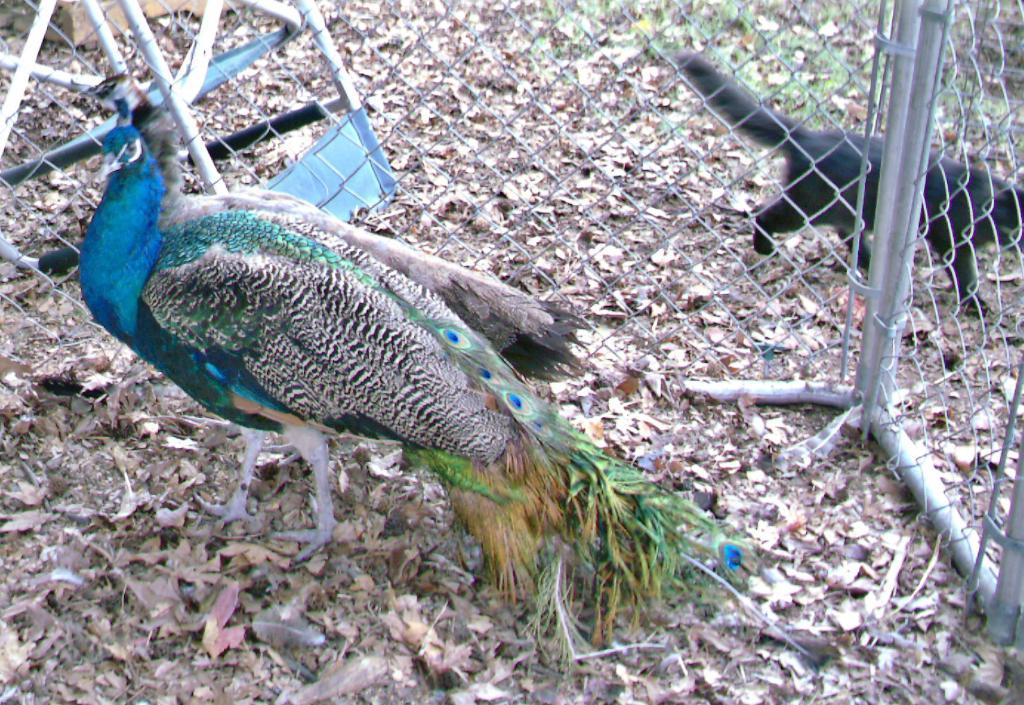What animal is the main subject of the image? There is a peacock in the image. Where is the peacock located in the image? The peacock is standing on the ground. What can be seen in the background of the image? There is a fence and a black color animal in the background of the image. What else is present on the ground in the background of the image? There are other objects on the ground in the background of the image. What scent is the committee emitting in the image? There is no committee present in the image, and therefore no scent can be attributed to it. 